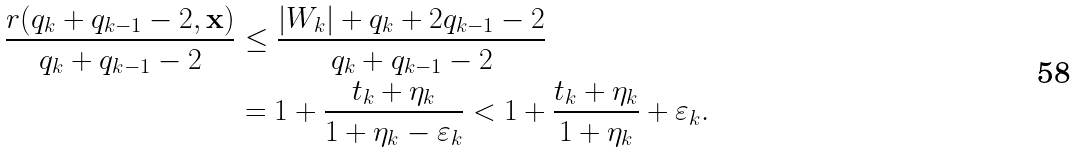<formula> <loc_0><loc_0><loc_500><loc_500>\frac { r ( q _ { k } + q _ { k - 1 } - 2 , { \mathbf x } ) } { q _ { k } + q _ { k - 1 } - 2 } & \leq \frac { | W _ { k } | + q _ { k } + 2 q _ { k - 1 } - 2 } { q _ { k } + q _ { k - 1 } - 2 } \\ & = 1 + \frac { t _ { k } + \eta _ { k } } { 1 + \eta _ { k } - \varepsilon _ { k } } < 1 + \frac { t _ { k } + \eta _ { k } } { 1 + \eta _ { k } } + \varepsilon _ { k } .</formula> 